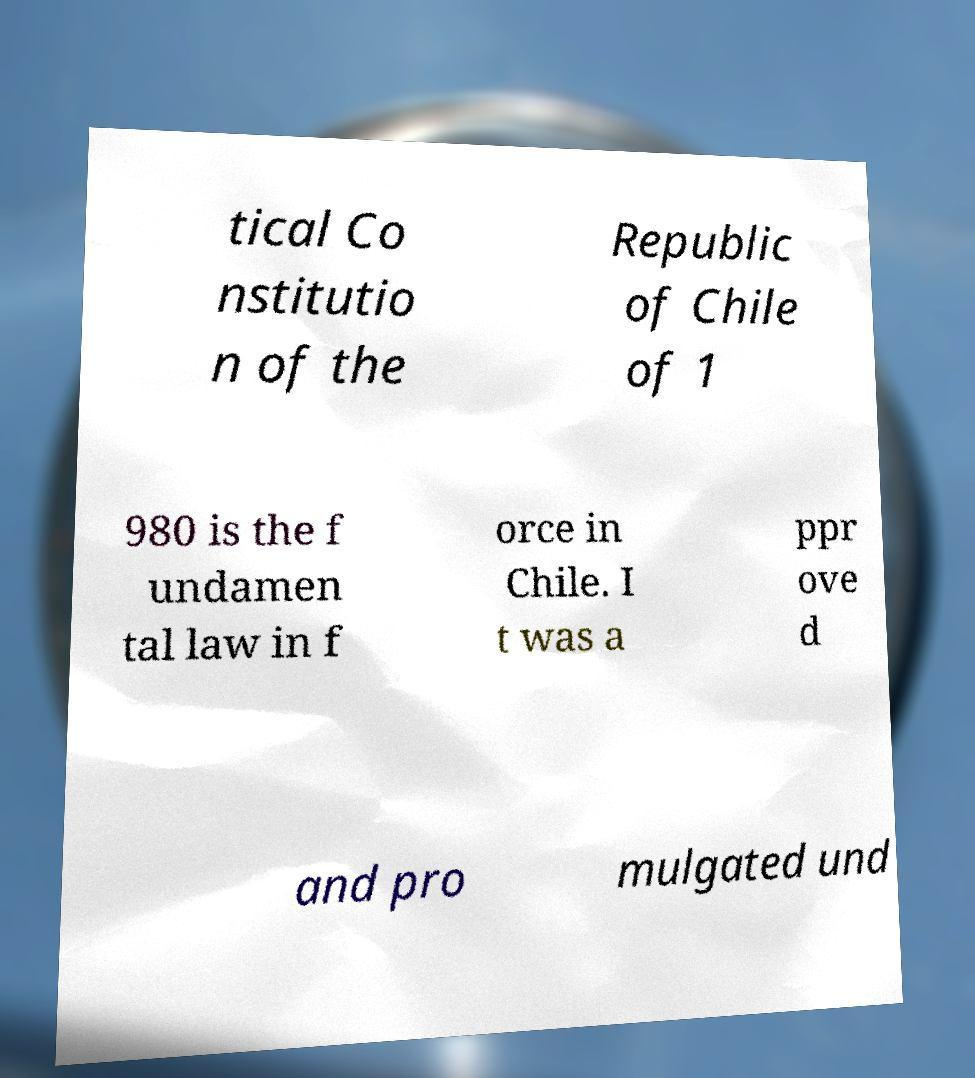There's text embedded in this image that I need extracted. Can you transcribe it verbatim? tical Co nstitutio n of the Republic of Chile of 1 980 is the f undamen tal law in f orce in Chile. I t was a ppr ove d and pro mulgated und 